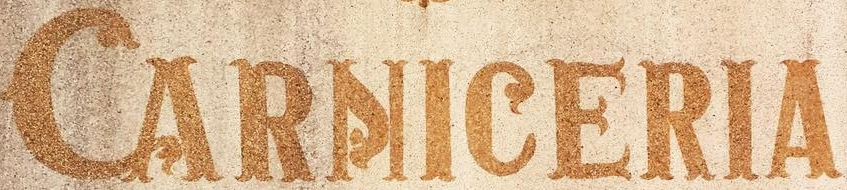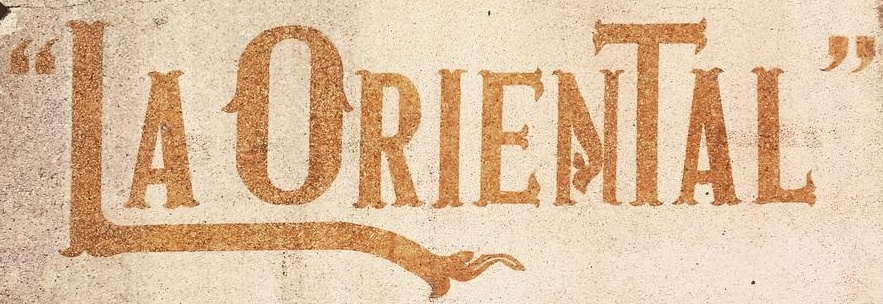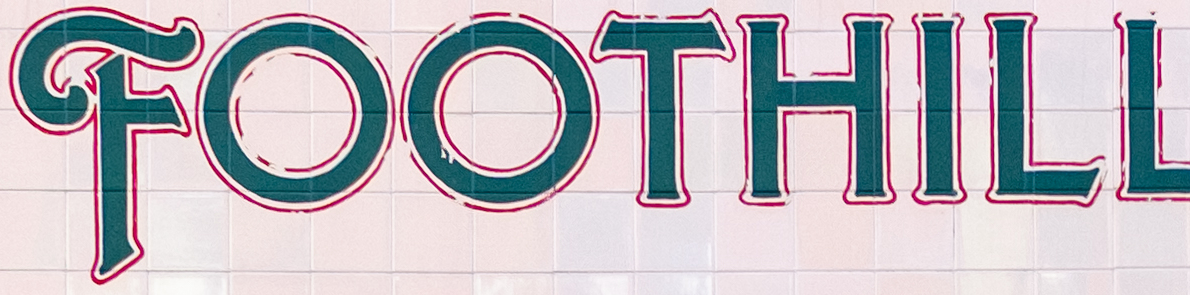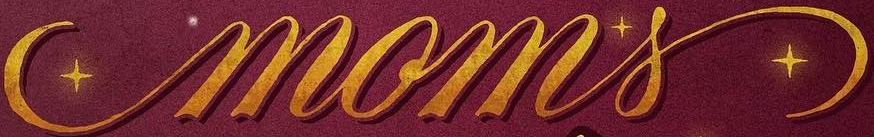Read the text from these images in sequence, separated by a semicolon. CARNICERIA; “LAORIENTAL"; FOOTHILL; moms 